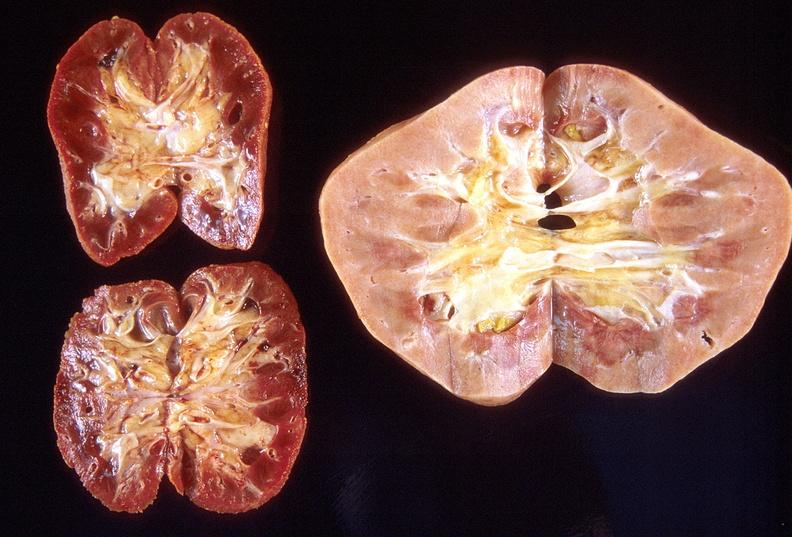does hemorrhagic corpus luteum show left - native end stage kidneys right - renal allograft abdominal?
Answer the question using a single word or phrase. No 